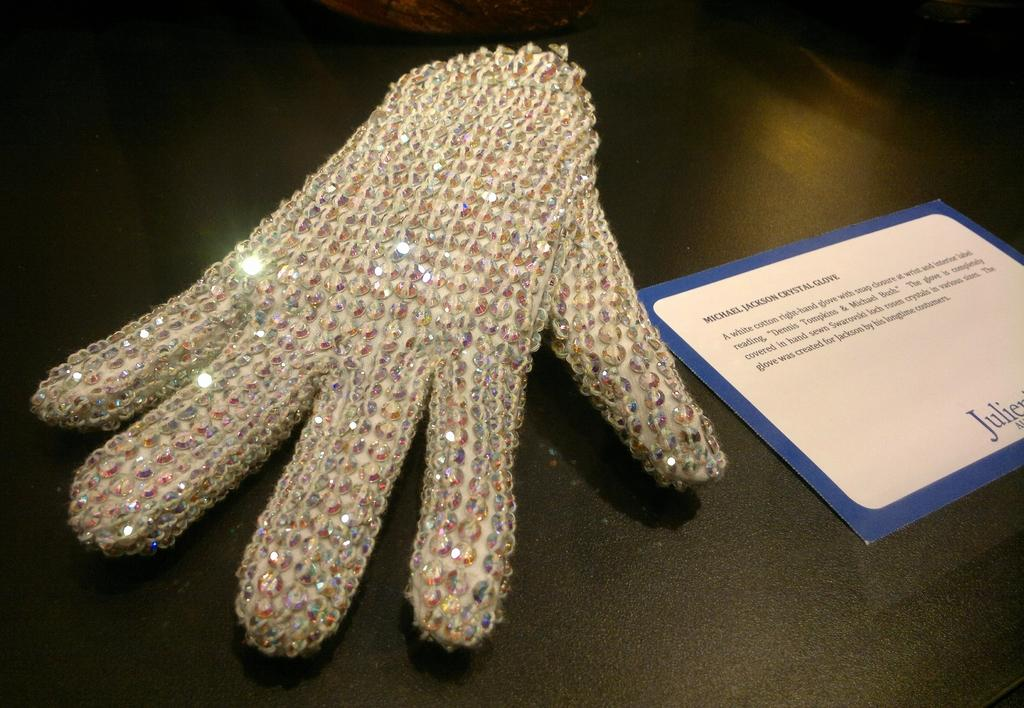What is there is a card with text in the image, what does the text say? The provided facts do not give information about the text on the card, so we cannot answer that question. What else is present in the image besides the card? There is a glove in the image. Where are the card and the glove located in the image? Both the card and the glove are placed on a surface. What type of powder is visible on the shelf in the image? There is no shelf or powder present in the image; it only features a card and a glove placed on a surface. 